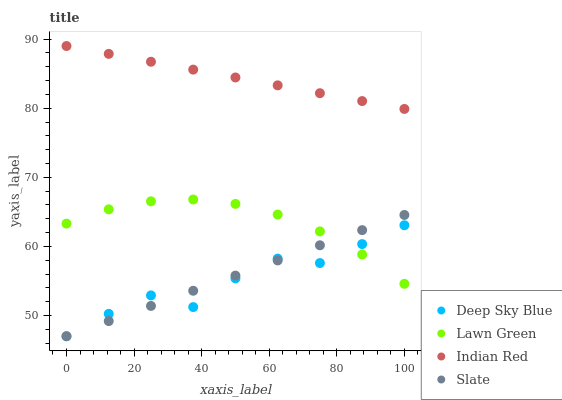Does Deep Sky Blue have the minimum area under the curve?
Answer yes or no. Yes. Does Indian Red have the maximum area under the curve?
Answer yes or no. Yes. Does Slate have the minimum area under the curve?
Answer yes or no. No. Does Slate have the maximum area under the curve?
Answer yes or no. No. Is Indian Red the smoothest?
Answer yes or no. Yes. Is Deep Sky Blue the roughest?
Answer yes or no. Yes. Is Slate the smoothest?
Answer yes or no. No. Is Slate the roughest?
Answer yes or no. No. Does Slate have the lowest value?
Answer yes or no. Yes. Does Indian Red have the lowest value?
Answer yes or no. No. Does Indian Red have the highest value?
Answer yes or no. Yes. Does Slate have the highest value?
Answer yes or no. No. Is Slate less than Indian Red?
Answer yes or no. Yes. Is Indian Red greater than Deep Sky Blue?
Answer yes or no. Yes. Does Lawn Green intersect Deep Sky Blue?
Answer yes or no. Yes. Is Lawn Green less than Deep Sky Blue?
Answer yes or no. No. Is Lawn Green greater than Deep Sky Blue?
Answer yes or no. No. Does Slate intersect Indian Red?
Answer yes or no. No. 